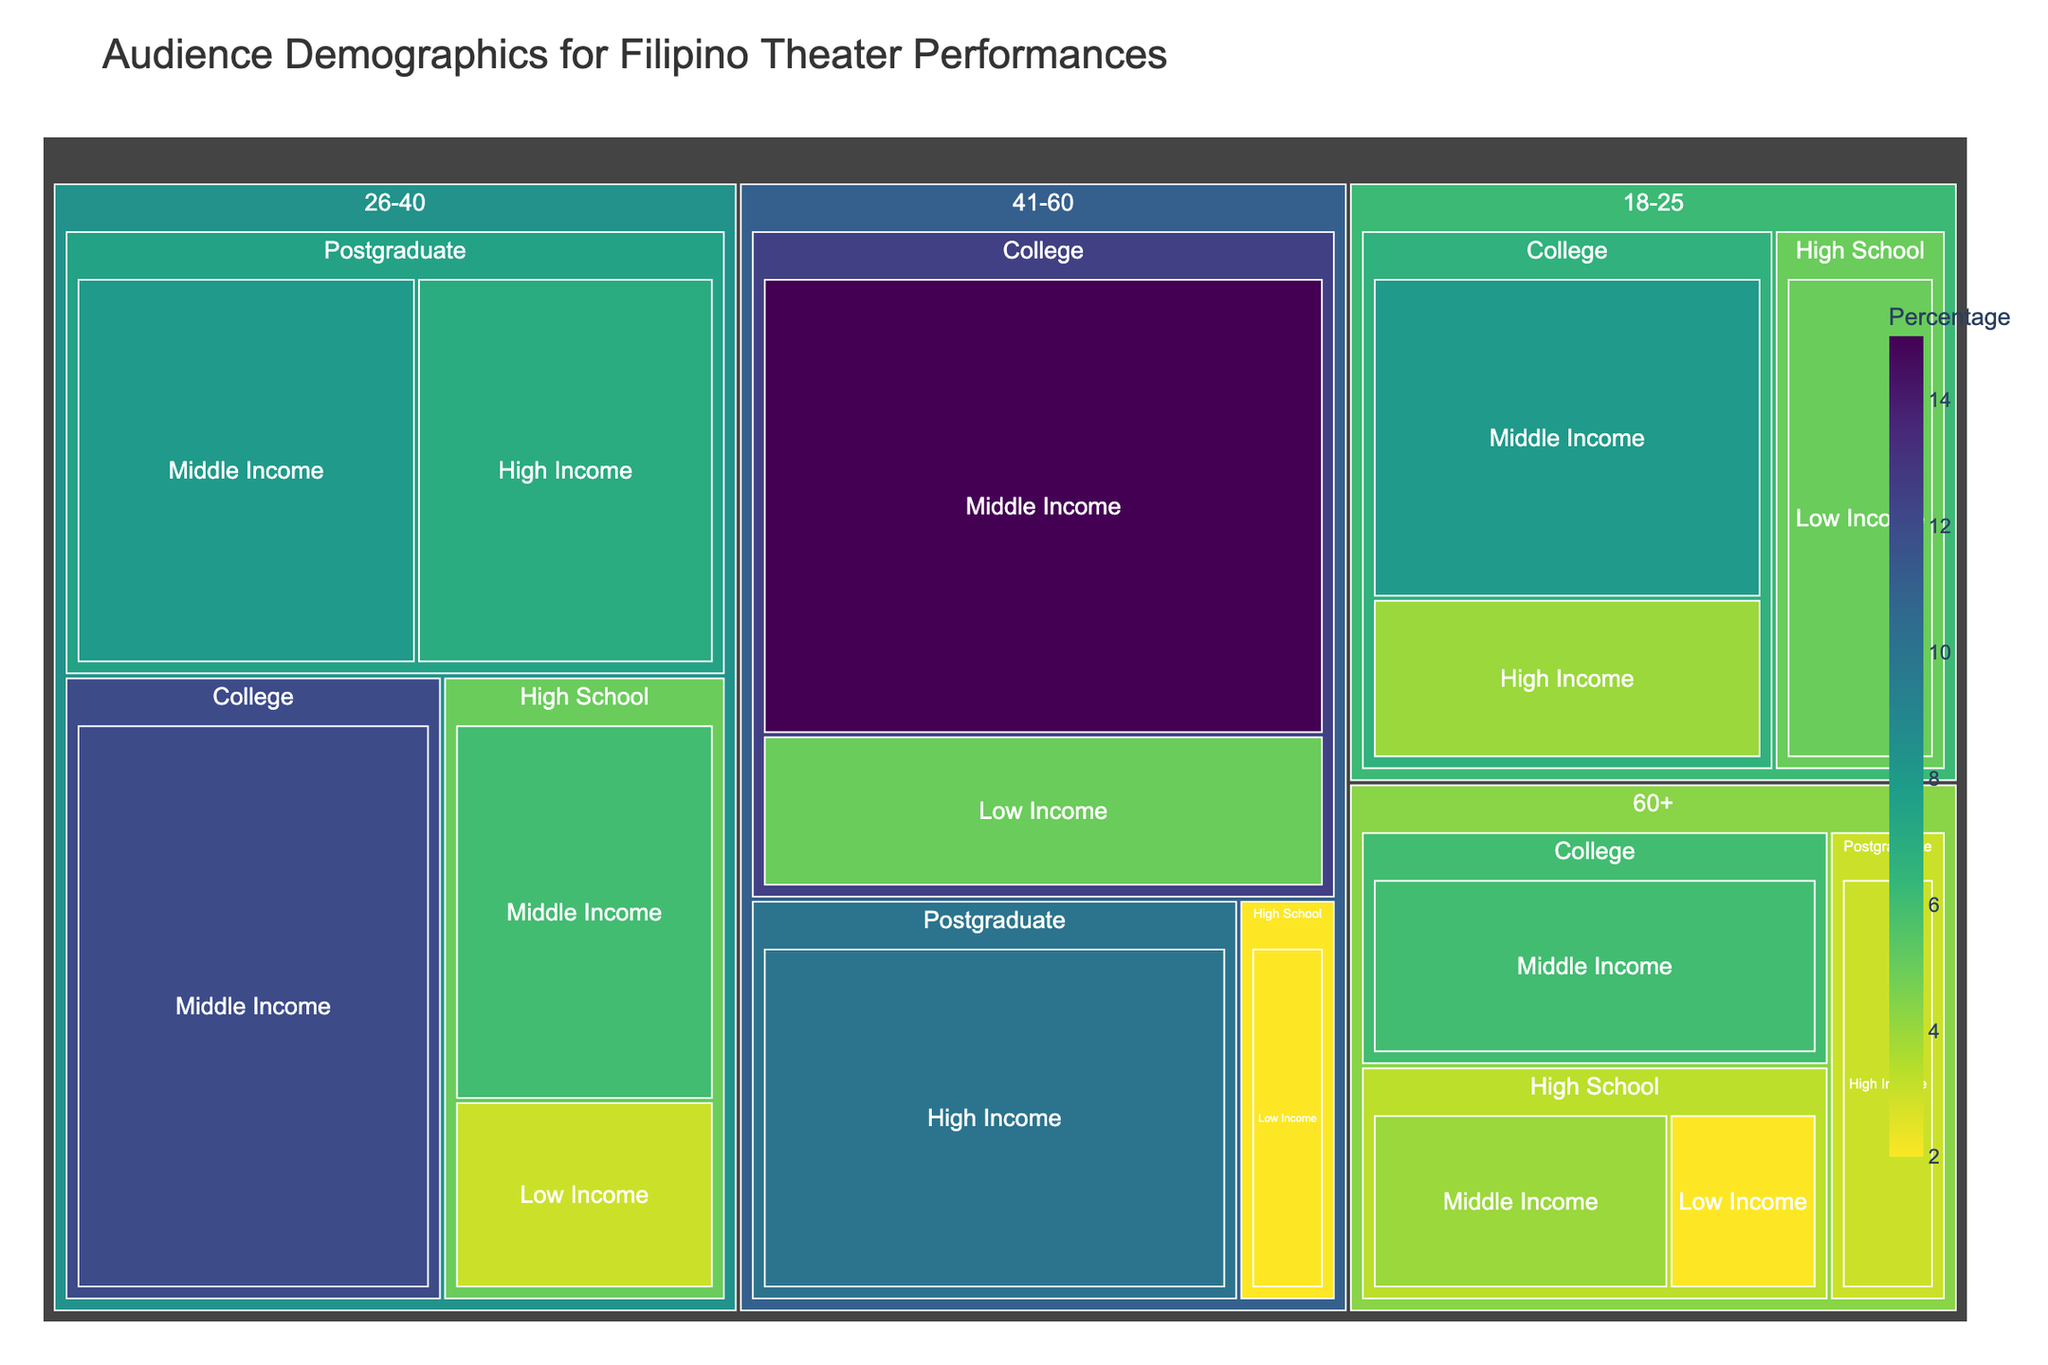What's the title of the figure? The title is shown at the top of the figure, typically in a larger font than the rest of the text. It provides a summary of what the figure represents.
Answer: Audience Demographics for Filipino Theater Performances What's the color scheme used in the figure? The color scheme of the figure can be seen by observing the colors used in the treemap. The provided description indicates the use of 'Viridis' color scale reversed, which manifests as a gradient from green to purple.
Answer: Green to Purple gradient Which age group has the highest overall percentage within a single education and socioeconomic status category? By examining the size of the segments in the treemap, one can determine the categories with the largest representations. The largest block within a single category is for '41-60, College, Middle Income' at 15%.
Answer: 41-60, College, Middle Income How do the percentages compare between '18-25, College, High Income' and '26-40, Postgraduate, High Income'? Locate the segments for '18-25, College, High Income' and '26-40, Postgraduate, High Income' within the treemap and compare their percentage values. '18-25, College, High Income' is 4%, while '26-40, Postgraduate, High Income' is 7%. 7% is greater than 4%.
Answer: '26-40, Postgraduate, High Income' has a higher percentage What is the sum of percentages for all high school education levels? Sum the values for all different age groups that have 'High School' as their education level: 5% (18-25, Low Income) + 3% (26-40, Low Income) + 2% (41-60, Low Income) + 4% (60+, Middle Income) + 2% (60+, Low Income) + 6% (26-40, Middle Income) = 22%
Answer: 22% Which socioeconomic status category has the lowest overall percentage across all age groups and education levels? Compare the total amounts for each socioeconomic status category by summing the percentages across different age groups and education for each category. 'Low Income' appears most frequently with lower percentages: 5+3+2+2+5 = 17%.
Answer: Low Income What's the total percentage representation for the age group 60+? Sum the percentages for all the subcategories under the age group '60+': 4% (Middle Income, High School) + 6% (Middle Income, College) + 3% (High Income, Postgraduate) + 2% (Low Income, High School) = 15%
Answer: 15% What is the largest percentage for a Postgraduate education level? Examine the treemap and identify the blocks labeled 'Postgraduate' within different age groups. The highest percentage is for '41-60, High Income' at 10%.
Answer: 10% Are there more attendees in the 26-40 age group with middle-income status compared to those with postgraduate education? Compare the segments for Middle Income and Postgraduate within the 26-40 age group. Middle Income includes High School (6%) and College (12%) for a total of 18%. Postgraduate only has two segments summing to 15% (8%+7%). 18% is greater than 15%.
Answer: Yes Which category combining age, education, and socioeconomic status has the smallest percentage? Identify the smallest segment in the treemap by comparing all the percentages for each combination. The smallest segment, '41-60, High School, Low Income,' has 2%, also shared by '60+, High School, Low Income'
Answer: 2% 